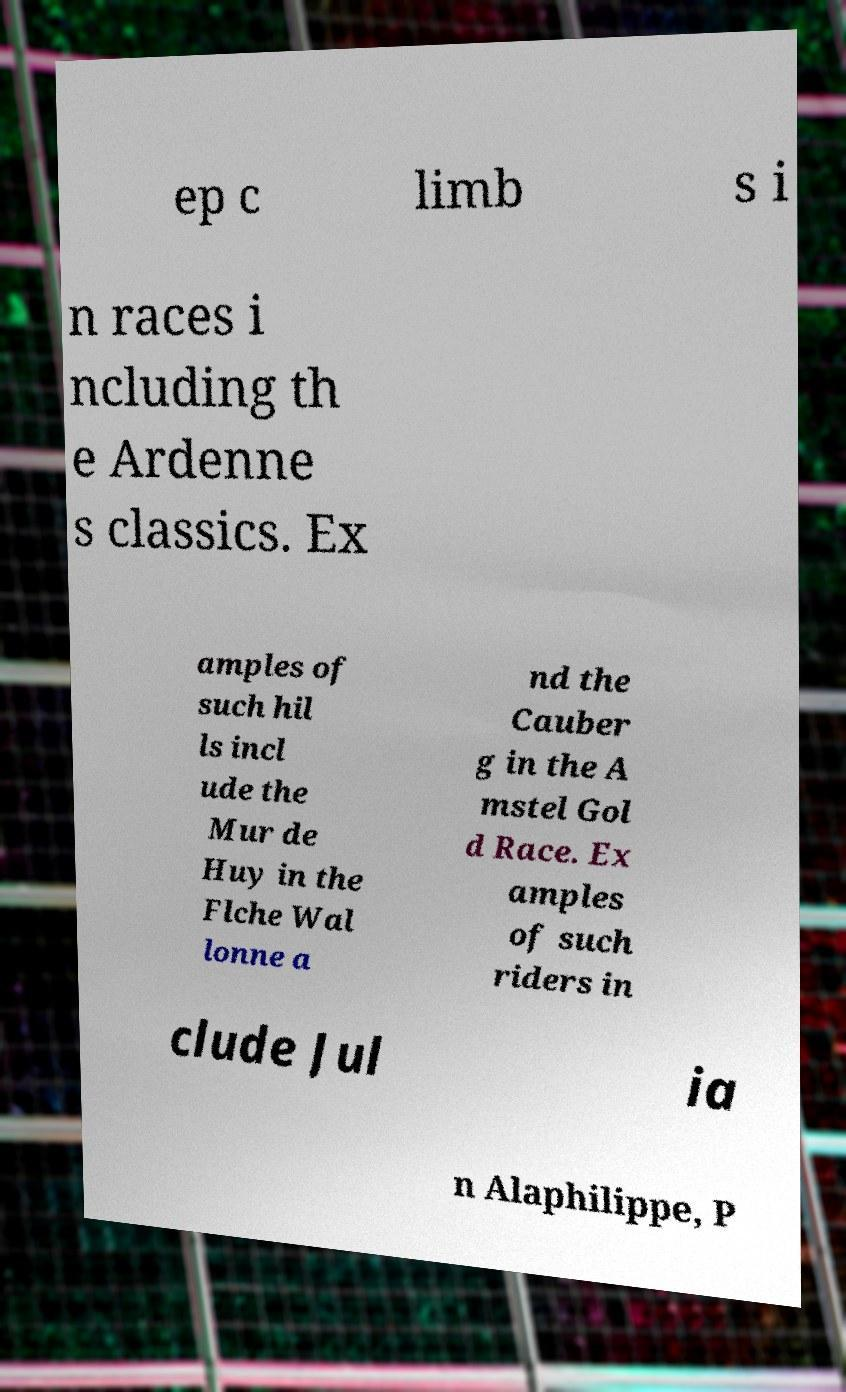For documentation purposes, I need the text within this image transcribed. Could you provide that? ep c limb s i n races i ncluding th e Ardenne s classics. Ex amples of such hil ls incl ude the Mur de Huy in the Flche Wal lonne a nd the Cauber g in the A mstel Gol d Race. Ex amples of such riders in clude Jul ia n Alaphilippe, P 